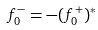<formula> <loc_0><loc_0><loc_500><loc_500>f ^ { - } _ { 0 } = - ( f ^ { + } _ { 0 } ) ^ { * }</formula> 